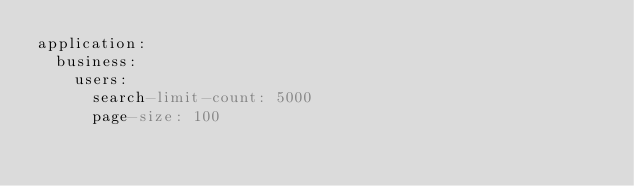Convert code to text. <code><loc_0><loc_0><loc_500><loc_500><_YAML_>application:
  business:
    users:
      search-limit-count: 5000
      page-size: 100
</code> 